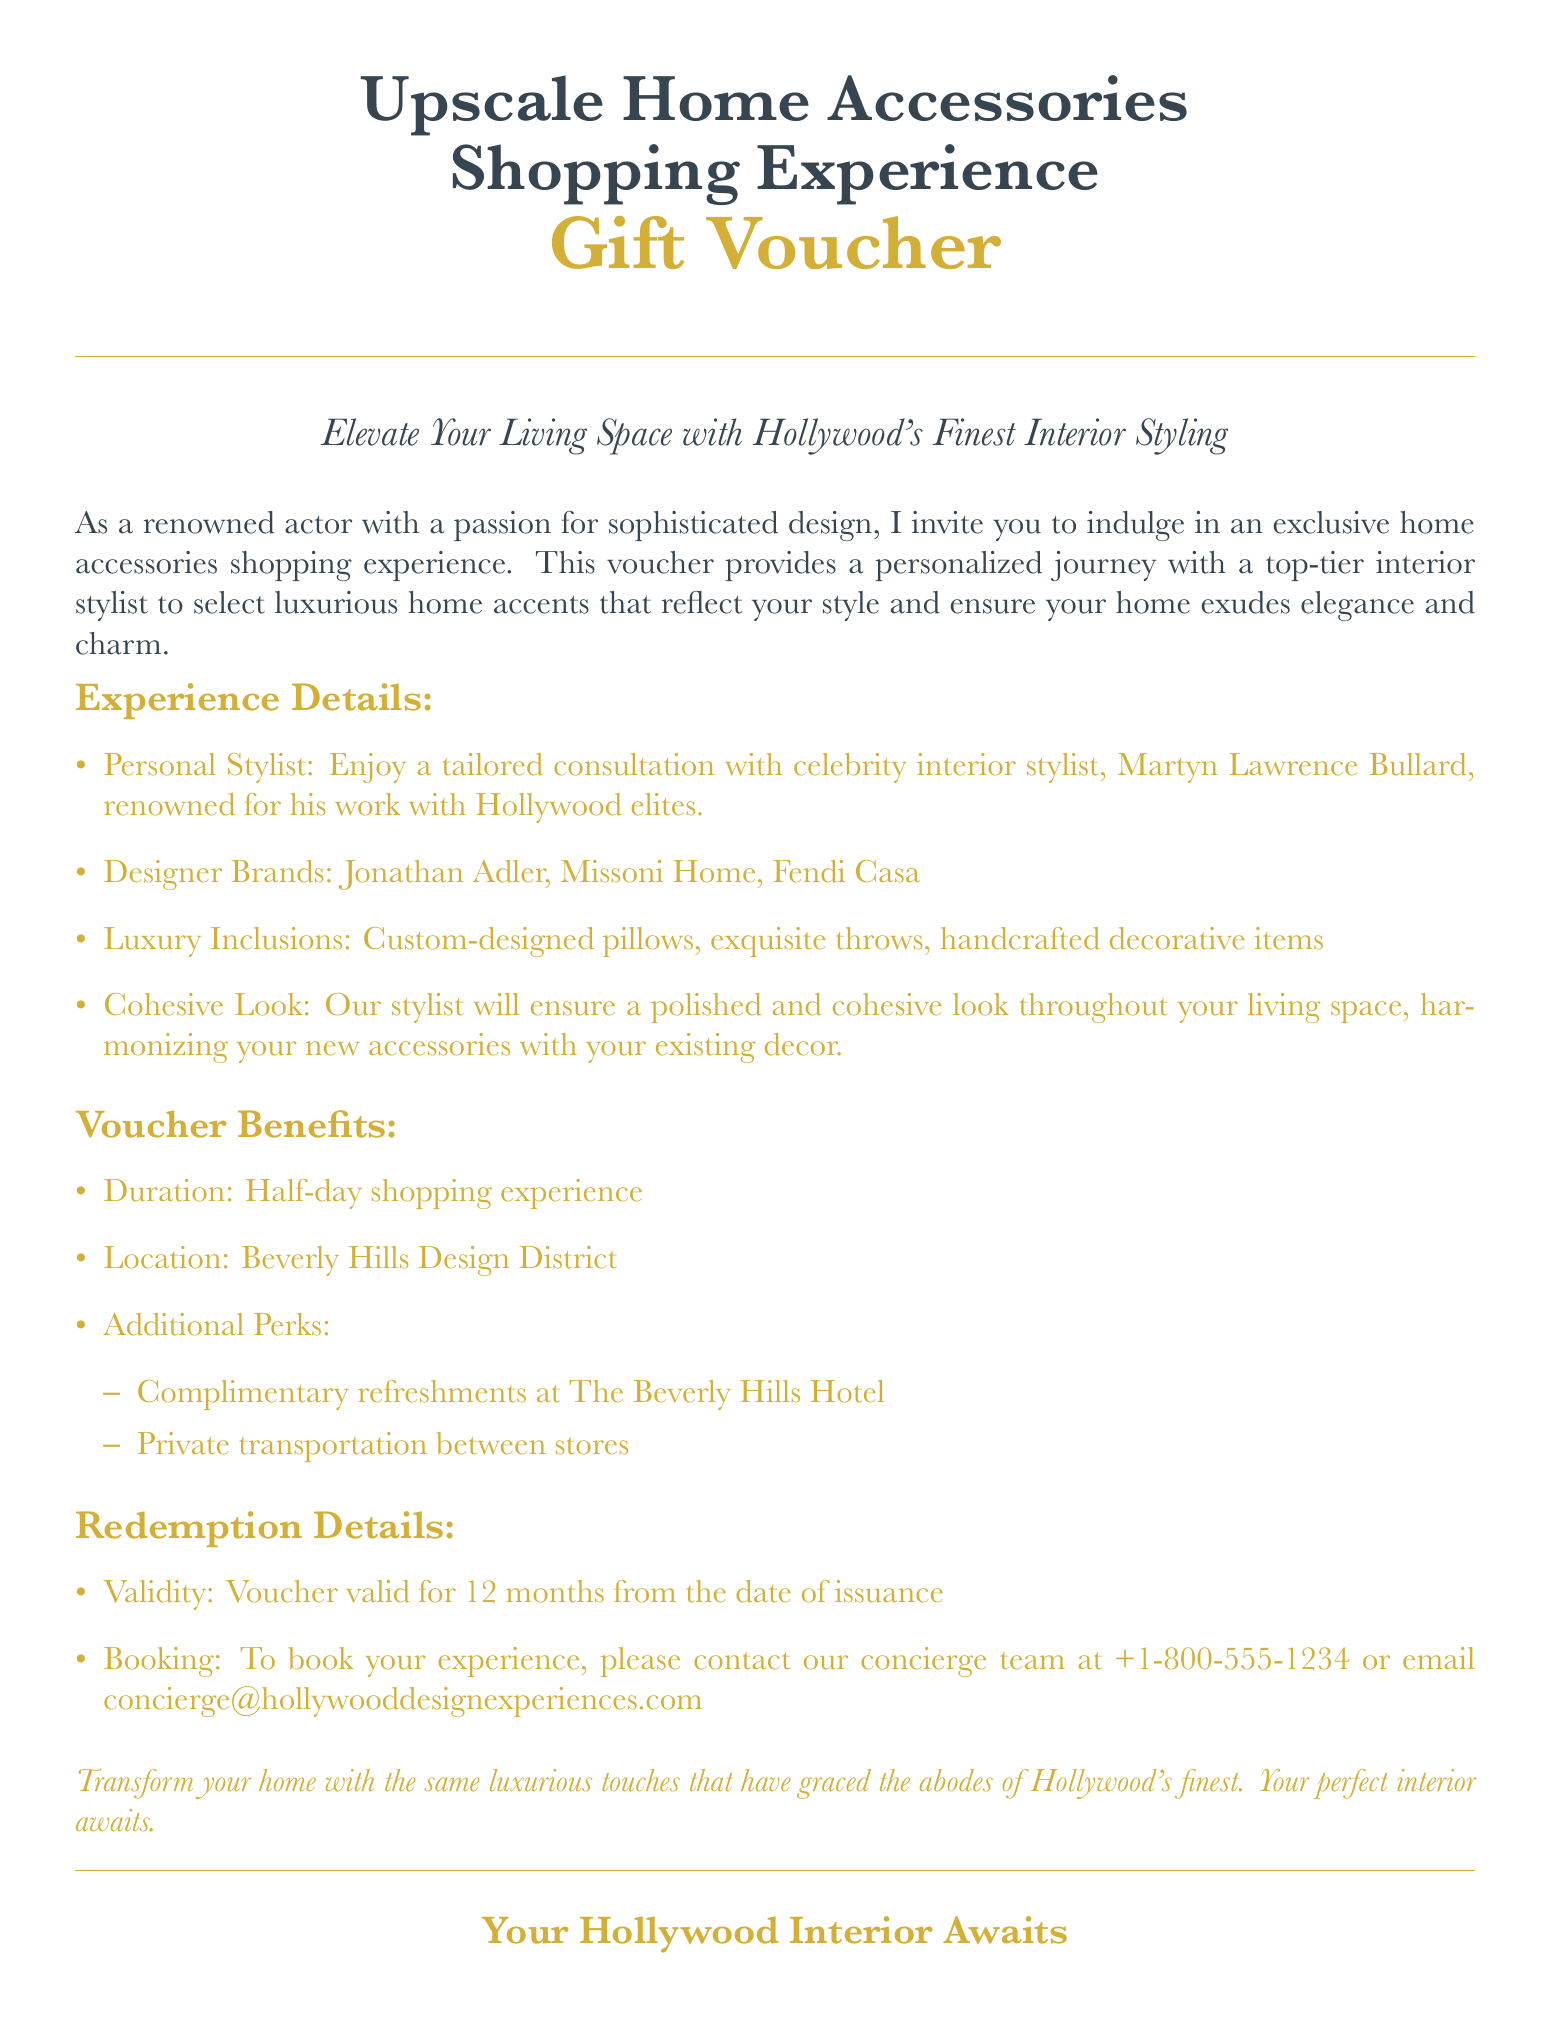what is the name of the interior stylist? The document states that the personal stylist for the experience is celebrity interior stylist Martyn Lawrence Bullard.
Answer: Martyn Lawrence Bullard what is the duration of the shopping experience? According to the document, the shopping experience lasts for a half-day.
Answer: Half-day what are two designer brands mentioned? The document lists several designer brands, including Jonathan Adler and Missoni Home.
Answer: Jonathan Adler, Missoni Home where is the shopping experience located? The location of the shopping experience is indicated as the Beverly Hills Design District in the document.
Answer: Beverly Hills Design District what kind of refreshments are included? The voucher mentions complimentary refreshments at The Beverly Hills Hotel as part of the perks.
Answer: Complimentary refreshments how long is the voucher valid for? The voucher is valid for 12 months from the date of issuance, as stated in the redemption details.
Answer: 12 months what will the stylist ensure during the shopping experience? The document specifies that the stylist will ensure a polished and cohesive look throughout the living space.
Answer: Polished and cohesive look what additional transportation is provided? The document mentions that private transportation between stores is included in the experience.
Answer: Private transportation 